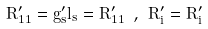Convert formula to latex. <formula><loc_0><loc_0><loc_500><loc_500>\tilde { R } _ { 1 1 } ^ { \prime } = g _ { s } ^ { \prime } l _ { s } = R _ { 1 1 } ^ { \prime } \ , \ \tilde { R } _ { i } ^ { \prime } = R _ { i } ^ { \prime }</formula> 